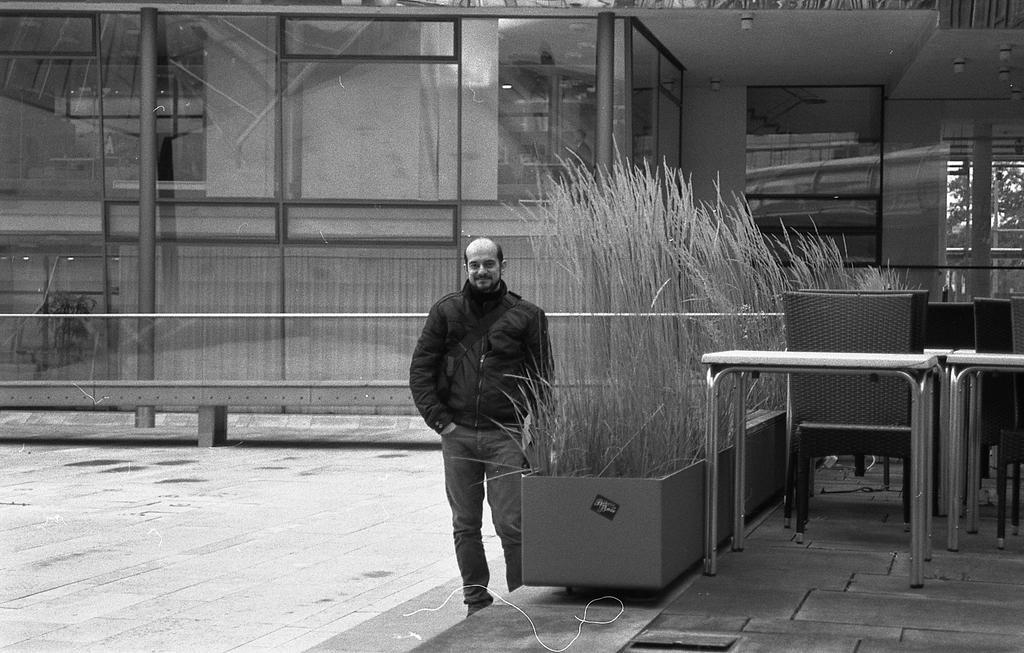Please provide a concise description of this image. In this image I can see the black and white picture in which I can see a person is standing on the ground, few plants, few tables, few chairs and a building. I can see the window of the building through which I can see few trees. 